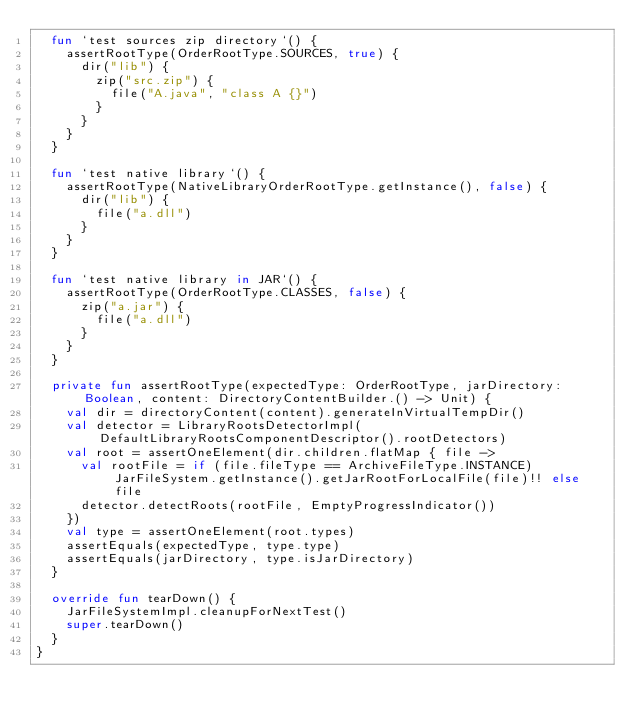Convert code to text. <code><loc_0><loc_0><loc_500><loc_500><_Kotlin_>  fun `test sources zip directory`() {
    assertRootType(OrderRootType.SOURCES, true) {
      dir("lib") {
        zip("src.zip") {
          file("A.java", "class A {}")
        }
      }
    }
  }

  fun `test native library`() {
    assertRootType(NativeLibraryOrderRootType.getInstance(), false) {
      dir("lib") {
        file("a.dll")
      }
    }
  }

  fun `test native library in JAR`() {
    assertRootType(OrderRootType.CLASSES, false) {
      zip("a.jar") {
        file("a.dll")
      }
    }
  }

  private fun assertRootType(expectedType: OrderRootType, jarDirectory: Boolean, content: DirectoryContentBuilder.() -> Unit) {
    val dir = directoryContent(content).generateInVirtualTempDir()
    val detector = LibraryRootsDetectorImpl(DefaultLibraryRootsComponentDescriptor().rootDetectors)
    val root = assertOneElement(dir.children.flatMap { file ->
      val rootFile = if (file.fileType == ArchiveFileType.INSTANCE) JarFileSystem.getInstance().getJarRootForLocalFile(file)!! else file
      detector.detectRoots(rootFile, EmptyProgressIndicator())
    })
    val type = assertOneElement(root.types)
    assertEquals(expectedType, type.type)
    assertEquals(jarDirectory, type.isJarDirectory)
  }

  override fun tearDown() {
    JarFileSystemImpl.cleanupForNextTest()
    super.tearDown()
  }
}</code> 